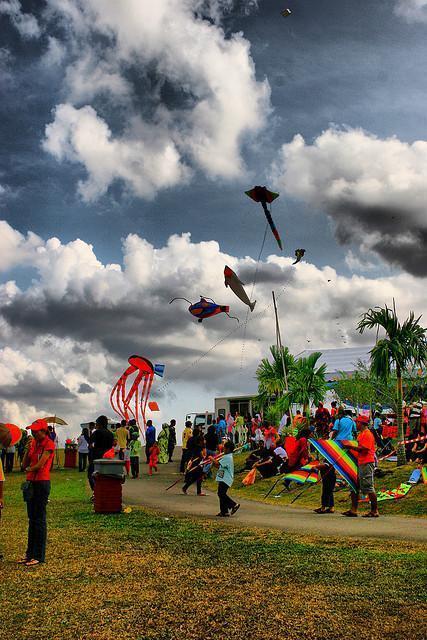How many kites are in the sky?
Give a very brief answer. 5. How many people are there?
Give a very brief answer. 2. 